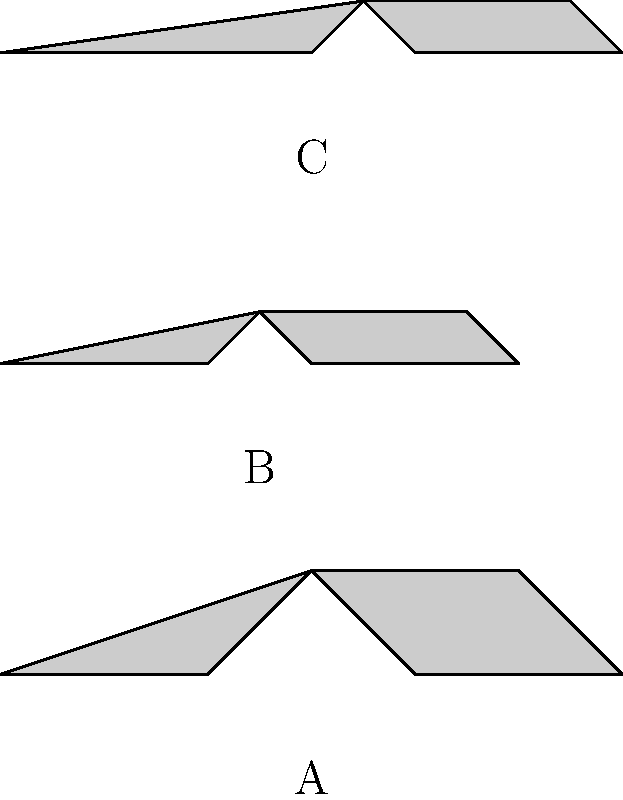Look at the airplane silhouettes above. Which one looks like it might have the biggest wings compared to its body? Let's look at each airplane silhouette carefully:

1. Airplane A (bottom): This plane has short wings compared to its long body.

2. Airplane B (middle): This plane has wings that are about the same length as its body.

3. Airplane C (top): This plane has wings that extend further out from its body compared to the other two planes.

When we compare the wing size to the body size, Airplane C appears to have the largest wings relative to its body. This type of plane with big wings is often used for long flights because big wings help the plane stay in the air for a long time.

Remember, as a young traveler, you might see planes like this from the airport windows. The plane with the biggest wings compared to its body is usually designed for longer flights across oceans or continents.
Answer: C 